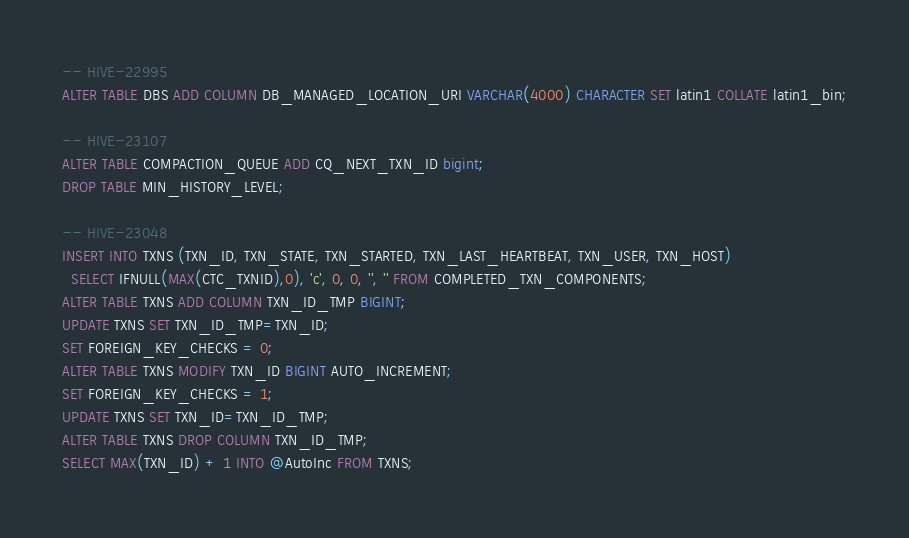<code> <loc_0><loc_0><loc_500><loc_500><_SQL_>
-- HIVE-22995
ALTER TABLE DBS ADD COLUMN DB_MANAGED_LOCATION_URI VARCHAR(4000) CHARACTER SET latin1 COLLATE latin1_bin;

-- HIVE-23107
ALTER TABLE COMPACTION_QUEUE ADD CQ_NEXT_TXN_ID bigint;
DROP TABLE MIN_HISTORY_LEVEL;

-- HIVE-23048
INSERT INTO TXNS (TXN_ID, TXN_STATE, TXN_STARTED, TXN_LAST_HEARTBEAT, TXN_USER, TXN_HOST)
  SELECT IFNULL(MAX(CTC_TXNID),0), 'c', 0, 0, '', '' FROM COMPLETED_TXN_COMPONENTS;
ALTER TABLE TXNS ADD COLUMN TXN_ID_TMP BIGINT;
UPDATE TXNS SET TXN_ID_TMP=TXN_ID;
SET FOREIGN_KEY_CHECKS = 0;
ALTER TABLE TXNS MODIFY TXN_ID BIGINT AUTO_INCREMENT;
SET FOREIGN_KEY_CHECKS = 1;
UPDATE TXNS SET TXN_ID=TXN_ID_TMP;
ALTER TABLE TXNS DROP COLUMN TXN_ID_TMP;
SELECT MAX(TXN_ID) + 1 INTO @AutoInc FROM TXNS;</code> 